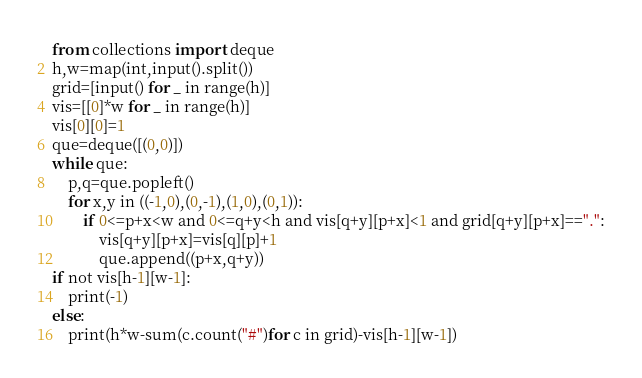<code> <loc_0><loc_0><loc_500><loc_500><_Python_>from collections import deque
h,w=map(int,input().split())
grid=[input() for _ in range(h)]
vis=[[0]*w for _ in range(h)]
vis[0][0]=1
que=deque([(0,0)])
while que:
	p,q=que.popleft()
	for x,y in ((-1,0),(0,-1),(1,0),(0,1)):
		if 0<=p+x<w and 0<=q+y<h and vis[q+y][p+x]<1 and grid[q+y][p+x]==".":
			vis[q+y][p+x]=vis[q][p]+1
			que.append((p+x,q+y))
if not vis[h-1][w-1]:
	print(-1)
else:
	print(h*w-sum(c.count("#")for c in grid)-vis[h-1][w-1])</code> 